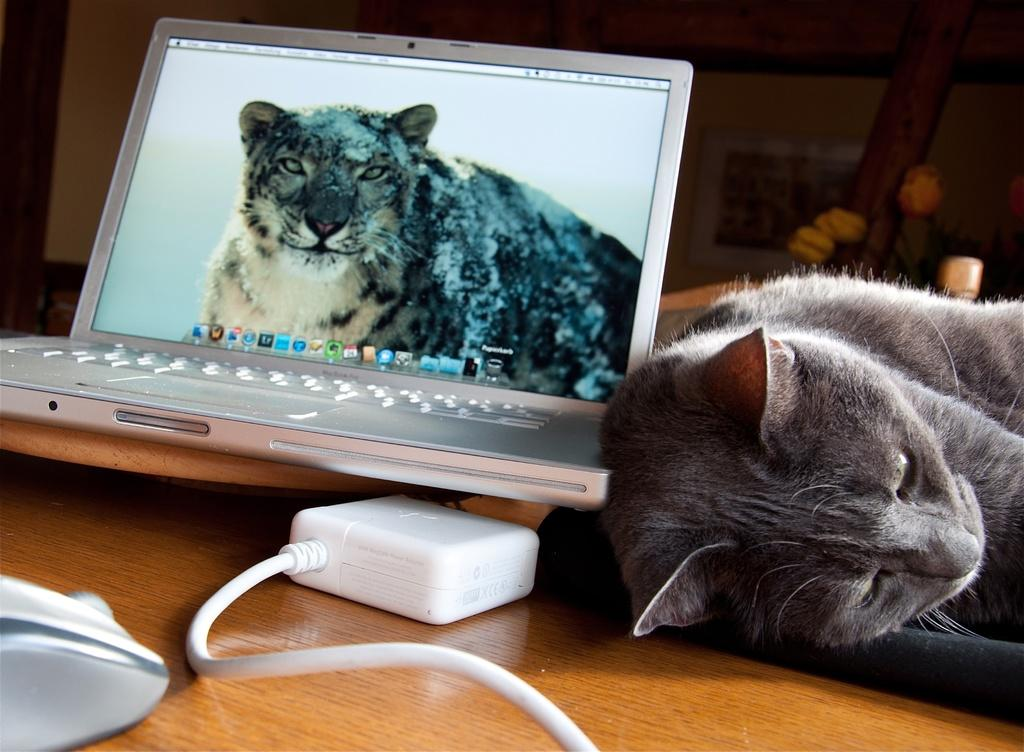What is the main piece of furniture in the image? There is a table in the image. What is lying on the table? A cat is lying on the table. What electronic device is on the table? There is a laptop on the table. What else can be seen on the table? There is a wire on the table. What is visible in the background of the image? There is a wall in the background of the image. What type of card is being played in the middle of the table? There is no card or card game present in the image; it features a table with a cat, laptop, and wire. What kind of seed is visible on the table? There is no seed present on the table in the image. 